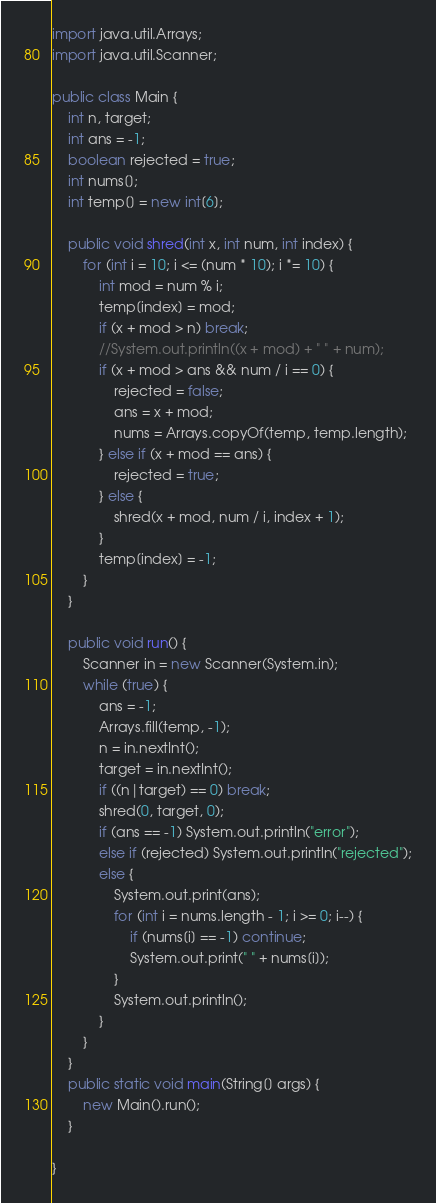<code> <loc_0><loc_0><loc_500><loc_500><_Java_>import java.util.Arrays;
import java.util.Scanner;

public class Main {
	int n, target;
	int ans = -1;
	boolean rejected = true;
	int nums[];
	int temp[] = new int[6];
	
	public void shred(int x, int num, int index) {
		for (int i = 10; i <= (num * 10); i *= 10) {
			int mod = num % i;
			temp[index] = mod;
			if (x + mod > n) break;
			//System.out.println((x + mod) + " " + num);
			if (x + mod > ans && num / i == 0) {
				rejected = false;
				ans = x + mod;
				nums = Arrays.copyOf(temp, temp.length);
			} else if (x + mod == ans) {
				rejected = true;
			} else {
				shred(x + mod, num / i, index + 1);
			}
			temp[index] = -1;
		}
	}
	
	public void run() {
		Scanner in = new Scanner(System.in);
		while (true) {
			ans = -1;
			Arrays.fill(temp, -1);
			n = in.nextInt();
			target = in.nextInt();
			if ((n|target) == 0) break;
			shred(0, target, 0);
			if (ans == -1) System.out.println("error");
			else if (rejected) System.out.println("rejected");
			else {
				System.out.print(ans);
				for (int i = nums.length - 1; i >= 0; i--) {
					if (nums[i] == -1) continue;
					System.out.print(" " + nums[i]);
				}
				System.out.println();
			}
		}
	}
	public static void main(String[] args) {
		new Main().run();
	}

}</code> 